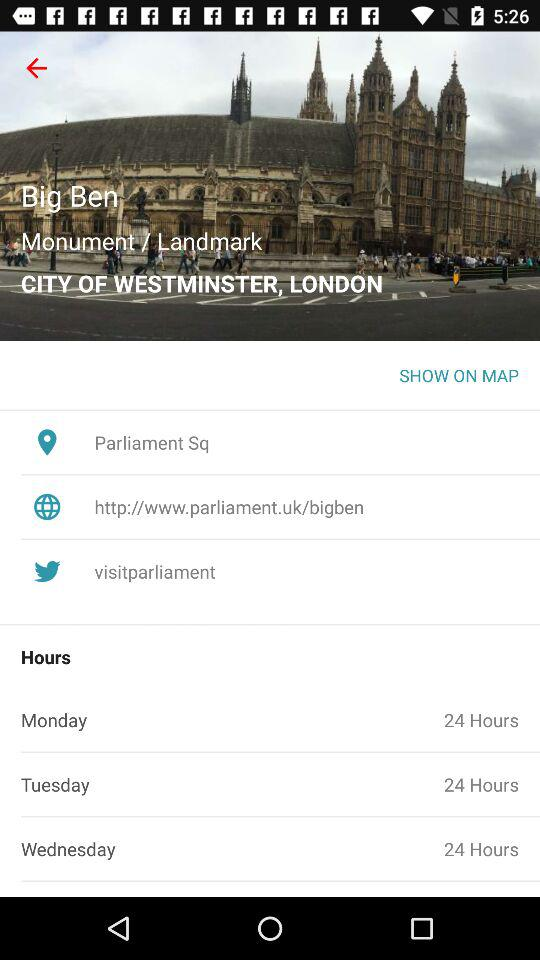What are the hours of Tuesday? The hours of Tuesday are 24. 